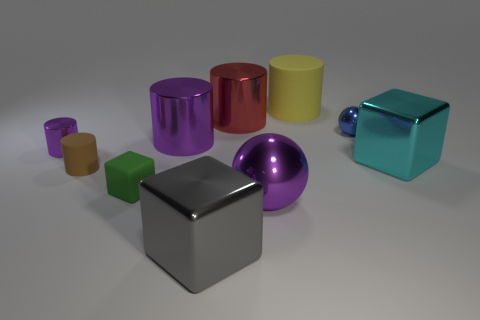How many shiny things are both on the left side of the yellow rubber thing and in front of the small purple cylinder?
Offer a terse response. 2. There is a purple thing left of the rubber cylinder that is in front of the red metal cylinder; what is it made of?
Provide a succinct answer. Metal. What material is the small purple thing that is the same shape as the red thing?
Keep it short and to the point. Metal. Are there any tiny brown things?
Offer a terse response. Yes. There is a cyan thing that is made of the same material as the tiny blue object; what shape is it?
Your response must be concise. Cube. What is the small thing to the right of the large matte cylinder made of?
Provide a short and direct response. Metal. There is a small thing that is on the right side of the yellow matte cylinder; is it the same color as the big rubber cylinder?
Your answer should be very brief. No. What is the size of the metallic ball behind the large shiny block behind the gray metal cube?
Offer a very short reply. Small. Are there more tiny things in front of the small green rubber object than brown cylinders?
Offer a very short reply. No. Is the size of the rubber cylinder on the right side of the red metal object the same as the brown object?
Give a very brief answer. No. 